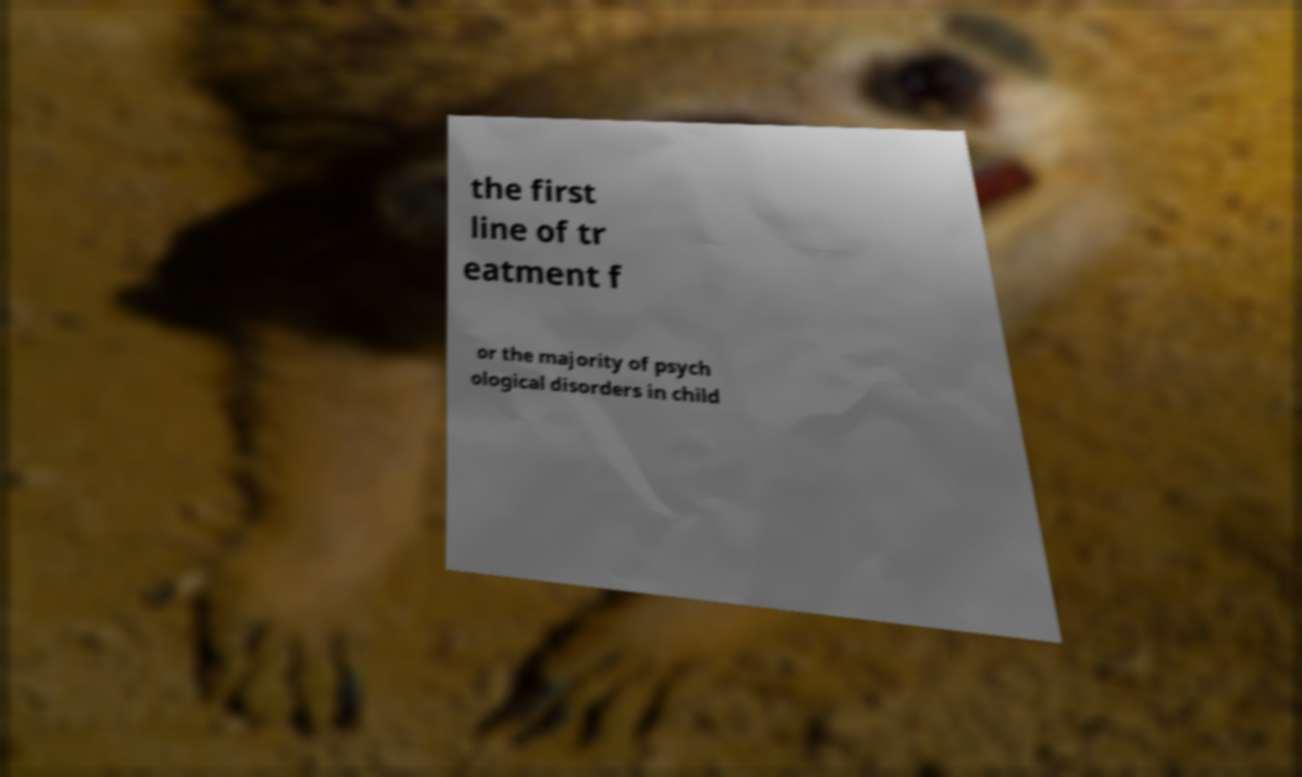For documentation purposes, I need the text within this image transcribed. Could you provide that? the first line of tr eatment f or the majority of psych ological disorders in child 